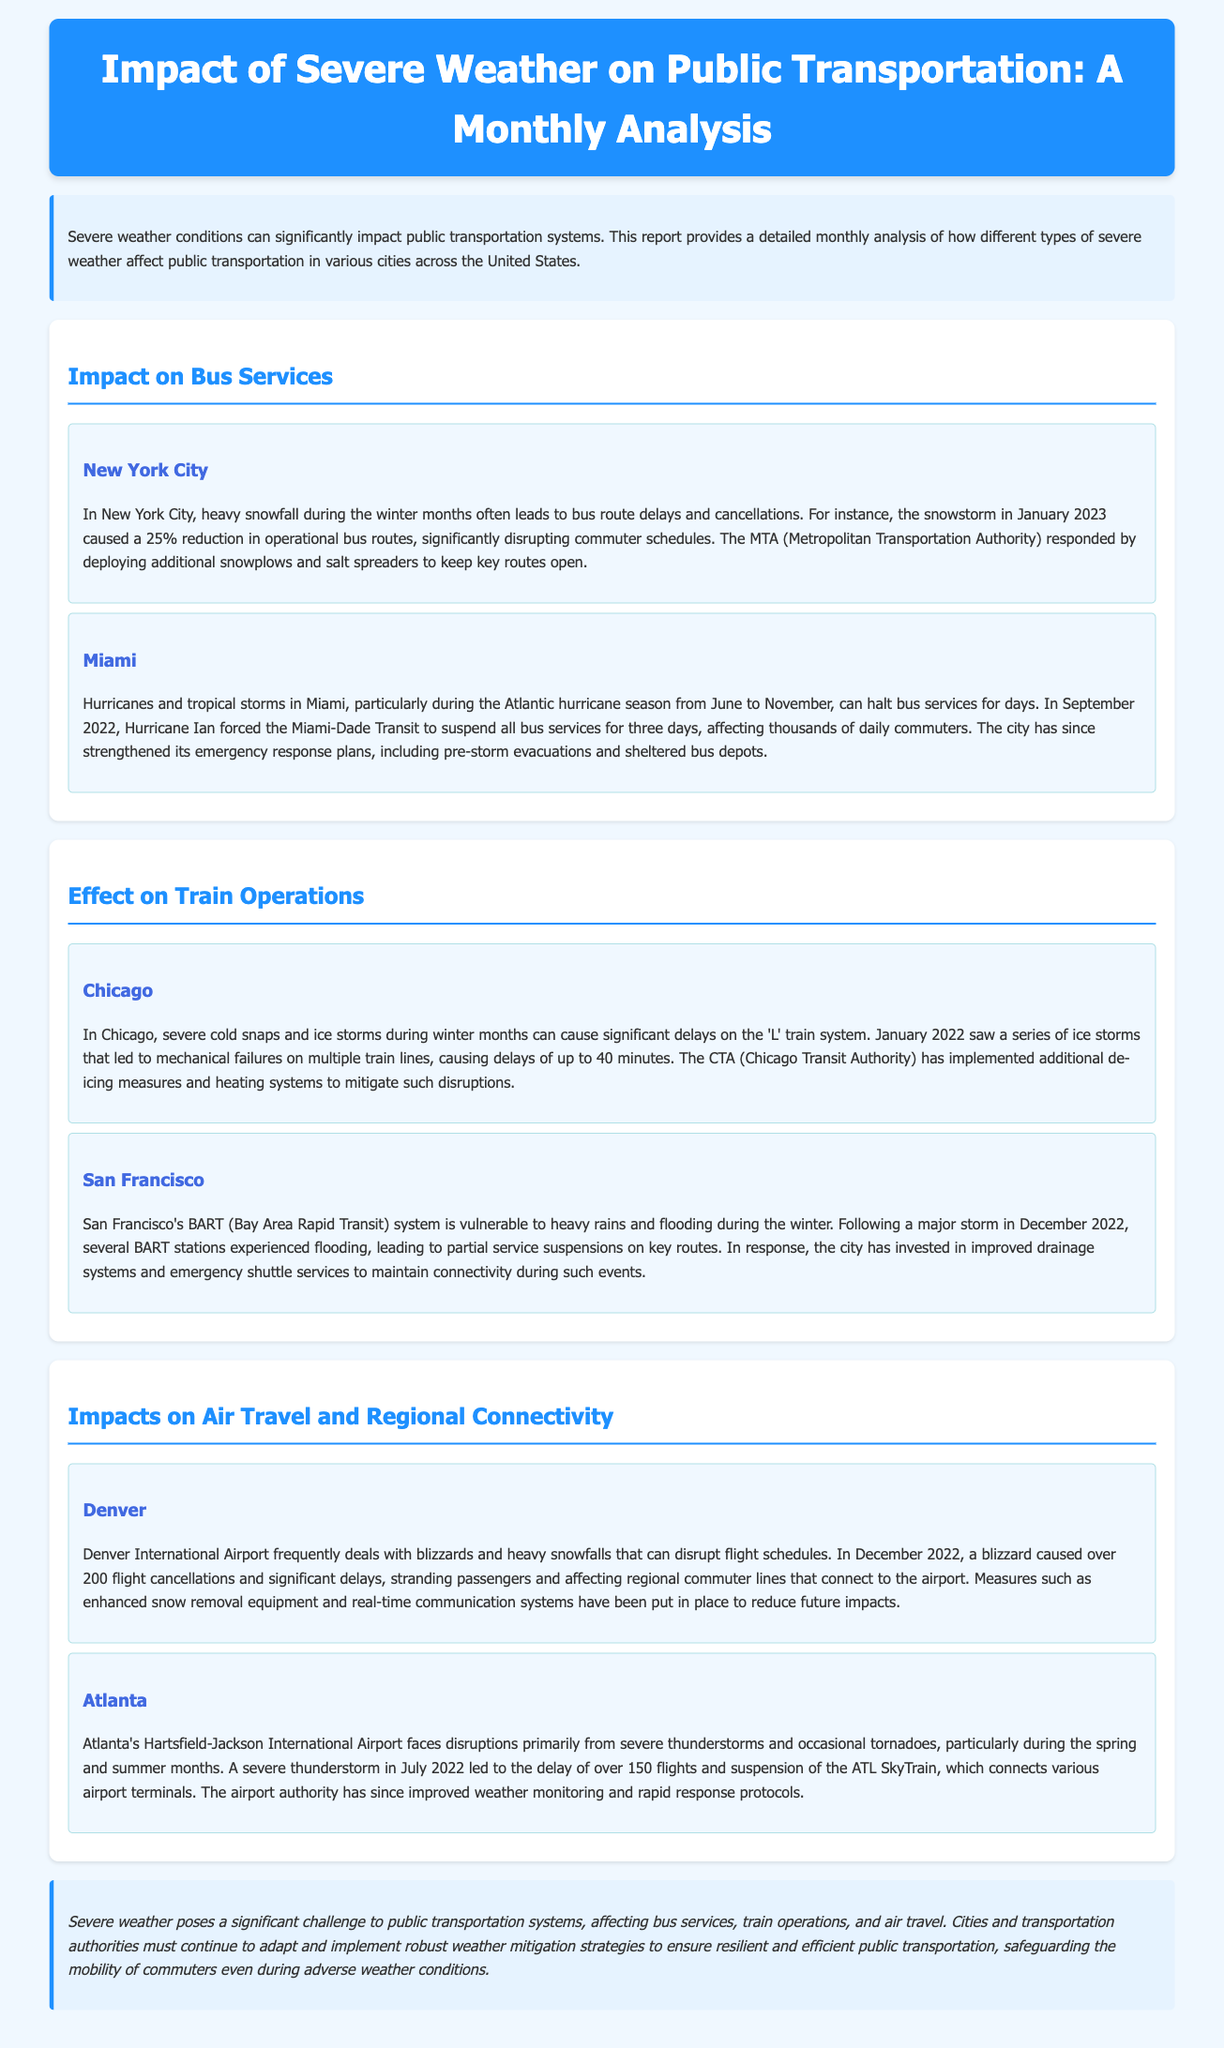What percentage of bus routes were reduced in New York City during the snowstorm? The report states that the snowstorm in January 2023 caused a 25% reduction in operational bus routes in New York City.
Answer: 25% How long did Hurricane Ian suspend bus services in Miami? According to the report, Hurricane Ian forced the Miami-Dade Transit to suspend all bus services for three days.
Answer: three days What weather condition affected Chicago's 'L' train system in January 2022? The report mentions that severe cold snaps and ice storms during winter months caused significant delays on the 'L' train system in Chicago.
Answer: ice storms Which city invested in improved drainage systems after flooding incidents? The section discusses San Francisco's BART system being vulnerable during the winter, leading the city to invest in improved drainage systems.
Answer: San Francisco What was the impact of the blizzard in December 2022 on Denver International Airport? The blizzard in December 2022 caused over 200 flight cancellations and significant delays at Denver International Airport.
Answer: over 200 flight cancellations What are the main weather events affecting Atlanta's Hartsfield-Jackson International Airport? The report indicates that severe thunderstorms and occasional tornadoes are the main weather events affecting Atlanta's airport during spring and summer.
Answer: severe thunderstorms and occasional tornadoes What action did Miami-Dade Transit take after Hurricane Ian? The report notes that Miami-Dade Transit strengthened its emergency response plans after the hurricane.
Answer: strengthened emergency response plans What measures has the CTA implemented to mitigate disruptions in Chicago? The report states that the Chicago Transit Authority has implemented additional de-icing measures and heating systems to mitigate disruptions.
Answer: additional de-icing measures and heating systems 